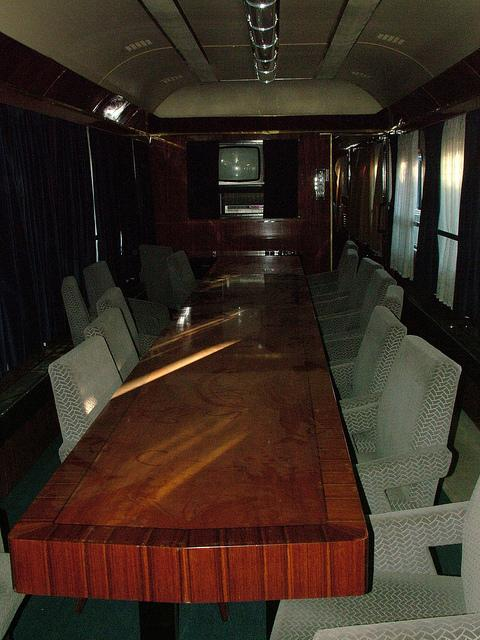The room here might be found where?

Choices:
A) luxury hotel
B) prison
C) car
D) train train 